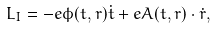Convert formula to latex. <formula><loc_0><loc_0><loc_500><loc_500>L _ { I } = - e \phi ( t , r ) \dot { t } + e A ( t , r ) \cdot \dot { r } ,</formula> 